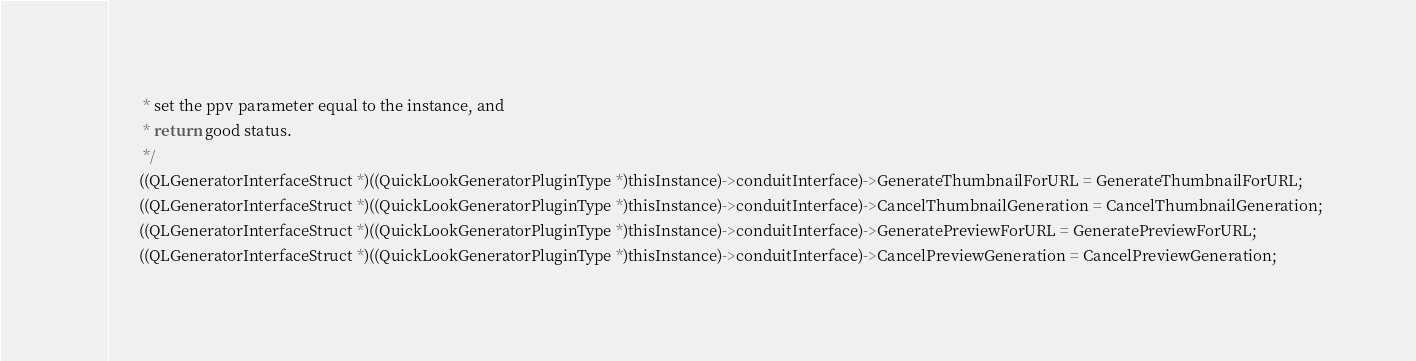<code> <loc_0><loc_0><loc_500><loc_500><_C_>         * set the ppv parameter equal to the instance, and
         * return good status.
         */
        ((QLGeneratorInterfaceStruct *)((QuickLookGeneratorPluginType *)thisInstance)->conduitInterface)->GenerateThumbnailForURL = GenerateThumbnailForURL;
        ((QLGeneratorInterfaceStruct *)((QuickLookGeneratorPluginType *)thisInstance)->conduitInterface)->CancelThumbnailGeneration = CancelThumbnailGeneration;
        ((QLGeneratorInterfaceStruct *)((QuickLookGeneratorPluginType *)thisInstance)->conduitInterface)->GeneratePreviewForURL = GeneratePreviewForURL;
        ((QLGeneratorInterfaceStruct *)((QuickLookGeneratorPluginType *)thisInstance)->conduitInterface)->CancelPreviewGeneration = CancelPreviewGeneration;</code> 